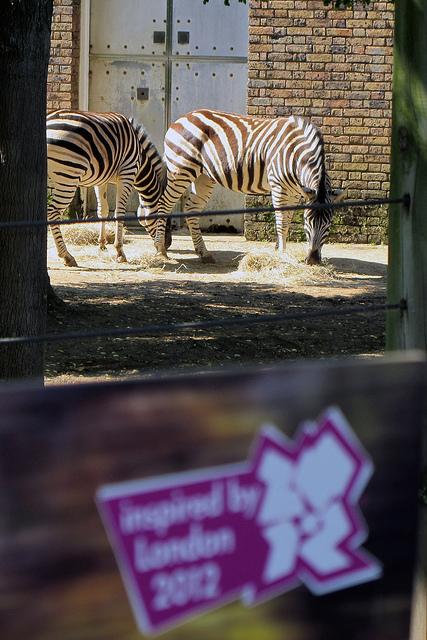What is the building made of?
Be succinct. Brick. How many animals are there?
Keep it brief. 2. What animals are they?
Keep it brief. Zebras. 